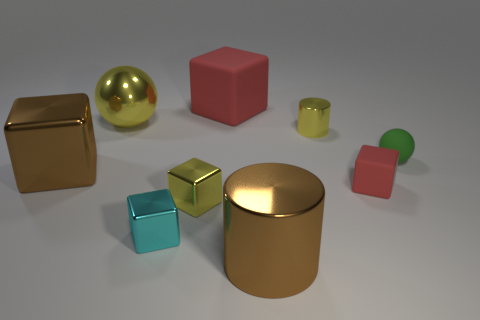Subtract all yellow cubes. How many cubes are left? 4 Subtract all large brown shiny blocks. How many blocks are left? 4 Subtract all gray blocks. Subtract all purple balls. How many blocks are left? 5 Add 1 yellow metal cylinders. How many objects exist? 10 Subtract all cylinders. How many objects are left? 7 Subtract 1 cyan cubes. How many objects are left? 8 Subtract all shiny blocks. Subtract all small green rubber things. How many objects are left? 5 Add 3 small green spheres. How many small green spheres are left? 4 Add 1 red rubber cubes. How many red rubber cubes exist? 3 